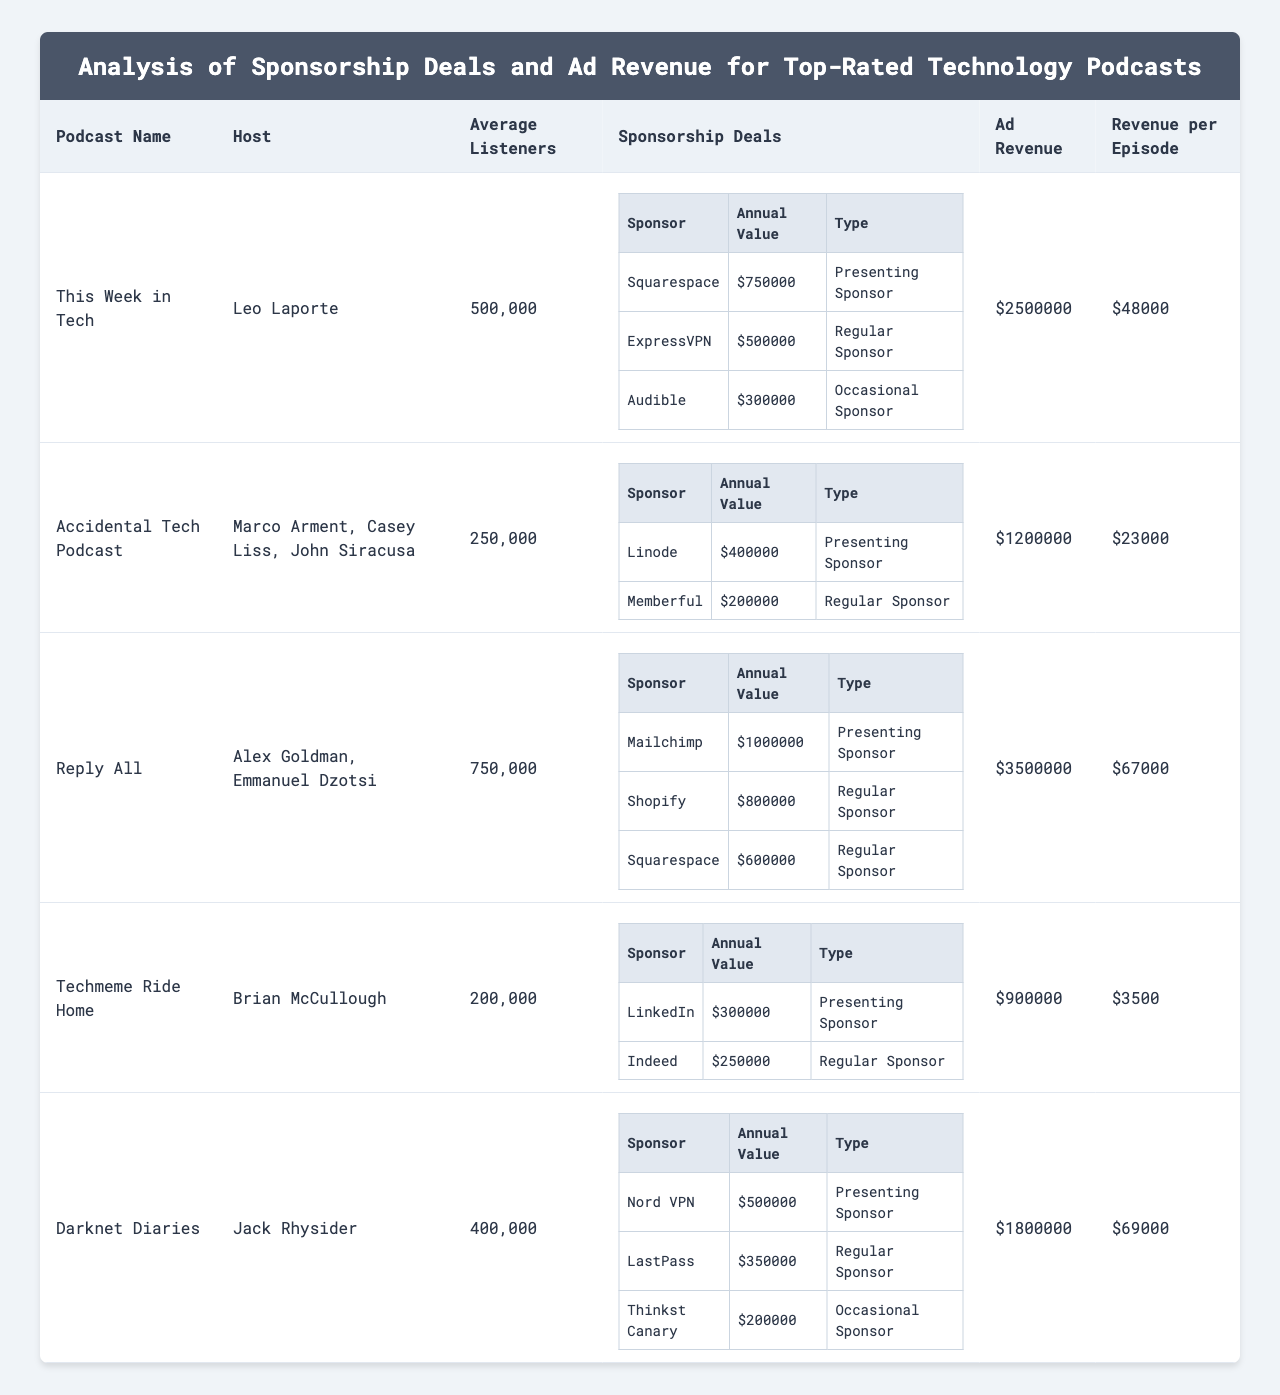What is the total annual value of sponsorship deals for "This Week in Tech"? The annual values of sponsorship deals for "This Week in Tech" are: $750,000 (Squarespace) + $500,000 (ExpressVPN) + $300,000 (Audible) = $1,550,000.
Answer: $1,550,000 Which podcast has the highest average listeners? "Reply All" has 750,000 average listeners, which is the highest when compared to the other podcasts in the table.
Answer: "Reply All" How much ad revenue does "Techmeme Ride Home" generate? The ad revenue for "Techmeme Ride Home" is listed directly in the table as $900,000.
Answer: $900,000 What is the revenue per episode for "Darknet Diaries"? The revenue per episode for "Darknet Diaries" is given directly in the table as $69,000.
Answer: $69,000 Which podcast has the lowest revenue per episode, and what is that value? "Techmeme Ride Home" has the lowest revenue per episode at $3,500 compared to others in the table.
Answer: $3,500 Is "Accidental Tech Podcast" a presenting sponsor for any deal? No, neither of the sponsorship deals listed for "Accidental Tech Podcast" (Linode and Memberful) are classified as a presenting sponsor.
Answer: No What is the total ad revenue for all listed podcasts? The total ad revenue is calculated by summing each podcast's ad revenue: $2,500,000 + $1,200,000 + $3,500,000 + $900,000 + $1,800,000 = $10,900,000.
Answer: $10,900,000 How many different sponsors does "Reply All" have, and what are their annual values? "Reply All" has three sponsors: Mailchimp ($1,000,000), Shopify ($800,000), and Squarespace ($600,000), totaling three distinct sponsorship agreements.
Answer: 3 sponsors What percentage of "Darknet Diaries" ad revenue comes from sponsorship deals relative to total ad revenue? To find the percentage, calculate the total sponsorship value: $500,000 (Nord VPN) + $350,000 (LastPass) + $200,000 (Thinkst Canary) = $1,050,000. Then the percentage is ($1,050,000 / $1,800,000) * 100 ≈ 58.33%.
Answer: 58.33% Which podcast's sponsorship deals add up to more than its ad revenue? "Techmeme Ride Home" has total sponsorship deals of $300,000 + $250,000 = $550,000, which is less than its ad revenue of $900,000; thus, no podcasts' deals exceed their ad revenue.
Answer: None 